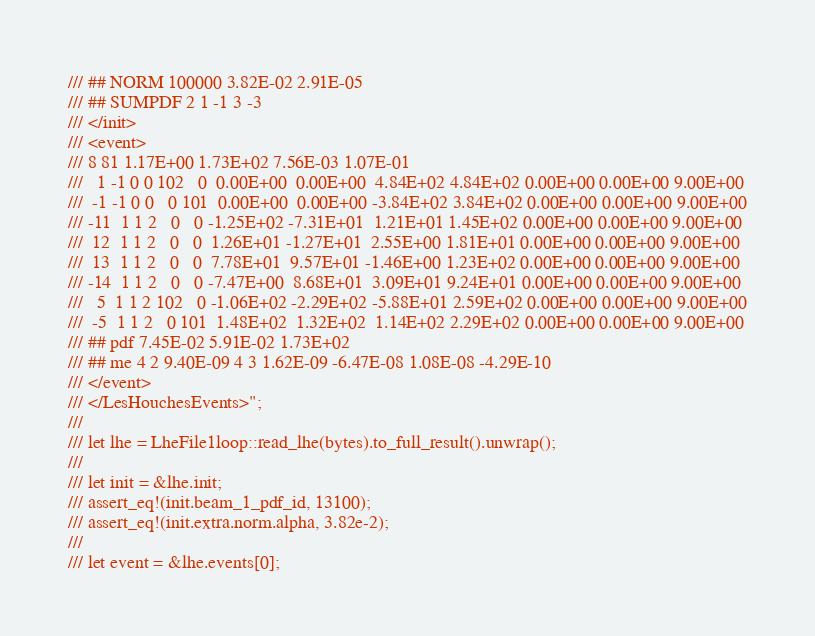<code> <loc_0><loc_0><loc_500><loc_500><_Rust_>/// ## NORM 100000 3.82E-02 2.91E-05
/// ## SUMPDF 2 1 -1 3 -3
/// </init>
/// <event>
/// 8 81 1.17E+00 1.73E+02 7.56E-03 1.07E-01
///   1 -1 0 0 102   0  0.00E+00  0.00E+00  4.84E+02 4.84E+02 0.00E+00 0.00E+00 9.00E+00
///  -1 -1 0 0   0 101  0.00E+00  0.00E+00 -3.84E+02 3.84E+02 0.00E+00 0.00E+00 9.00E+00
/// -11  1 1 2   0   0 -1.25E+02 -7.31E+01  1.21E+01 1.45E+02 0.00E+00 0.00E+00 9.00E+00
///  12  1 1 2   0   0  1.26E+01 -1.27E+01  2.55E+00 1.81E+01 0.00E+00 0.00E+00 9.00E+00
///  13  1 1 2   0   0  7.78E+01  9.57E+01 -1.46E+00 1.23E+02 0.00E+00 0.00E+00 9.00E+00
/// -14  1 1 2   0   0 -7.47E+00  8.68E+01  3.09E+01 9.24E+01 0.00E+00 0.00E+00 9.00E+00
///   5  1 1 2 102   0 -1.06E+02 -2.29E+02 -5.88E+01 2.59E+02 0.00E+00 0.00E+00 9.00E+00
///  -5  1 1 2   0 101  1.48E+02  1.32E+02  1.14E+02 2.29E+02 0.00E+00 0.00E+00 9.00E+00
/// ## pdf 7.45E-02 5.91E-02 1.73E+02
/// ## me 4 2 9.40E-09 4 3 1.62E-09 -6.47E-08 1.08E-08 -4.29E-10
/// </event>
/// </LesHouchesEvents>";
///
/// let lhe = LheFile1loop::read_lhe(bytes).to_full_result().unwrap();
///
/// let init = &lhe.init;
/// assert_eq!(init.beam_1_pdf_id, 13100);
/// assert_eq!(init.extra.norm.alpha, 3.82e-2);
///
/// let event = &lhe.events[0];</code> 